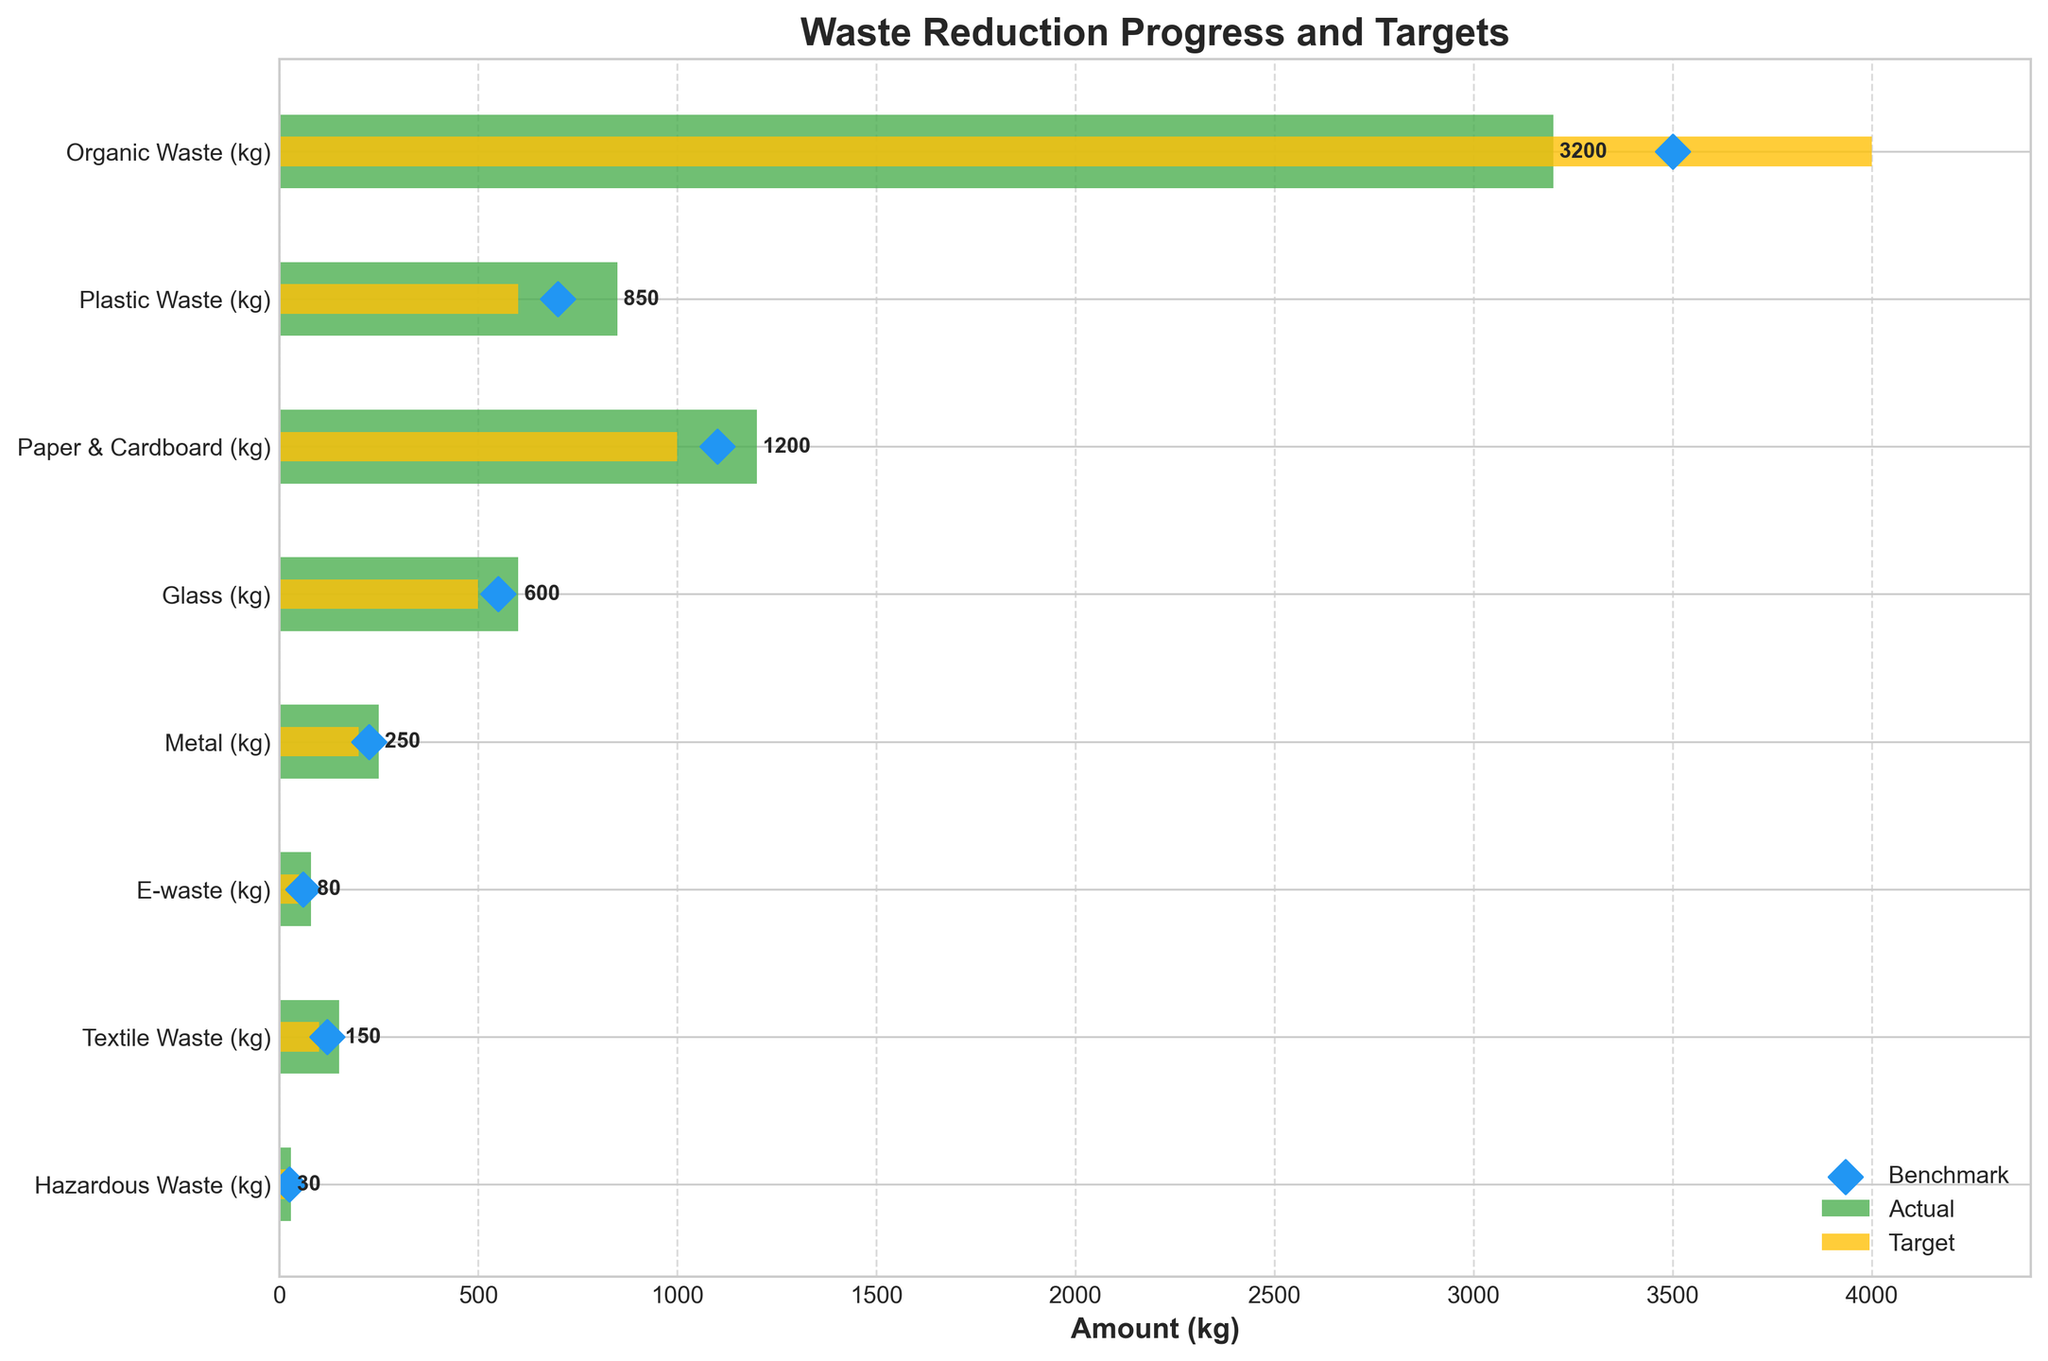Which category has the highest actual waste? By observing the actual values represented by the green bars, the Organic Waste category has the longest bar, indicating the highest actual waste.
Answer: Organic Waste Which category exceeded its target the most in terms of actual waste? To determine this, we compare the difference between the actual waste (green bars) and the target waste (yellow bars). Plastic Waste exceeds its target by the largest amount. The difference is 850 - 600 = 250 kg.
Answer: Plastic Waste What is the total actual waste from all categories? To find the total actual waste, sum all the actual values: 3200 (Organic) + 850 (Plastic) + 1200 (Paper & Cardboard) + 600 (Glass) + 250 (Metal) + 80 (E-waste) + 150 (Textile) + 30 (Hazardous). The sum is 6360 kg.
Answer: 6360 kg Which categories have actual waste values below their benchmarks? We compare the positions of the green bars (actuals) with blue diamonds (benchmarks). Plastic Waste, Paper & Cardboard, Glass, Metal, and Textile Waste have actual values above their benchmarks.
Answer: E-waste and Hazardous Waste What is the average target waste across all categories? To find the average target waste, sum all target values and divide by the number of categories: (4000 + 600 + 1000 + 500 + 200 + 50 + 100 + 20) / 8 = 6470 / 8 = 808.75 kg.
Answer: 808.75 kg Which category has the least variance between actual and benchmark values? To find this, calculate the absolute differences between actual values (green bars) and benchmark values (blue diamonds). The Metal category has an actual of 250 kg and a benchmark of 225 kg, resulting in the smallest difference of 250 - 225 = 25 kg.
Answer: Metal Are there any categories where the actual waste is less than the target but more than the benchmark? We look for categories where the green bar (actual) is between the yellow bar (target) and the blue diamond (benchmark). Paper & Cardboard fits this criterion because its actual waste (1200 kg) is less than the target (1000 kg) but more than the benchmark (1100 kg).
Answer: Paper & Cardboard Which category shows the best performance in terms of actual waste reduction compared to the target? The category where the actual waste is farthest below the target indicates better performance. E-waste shows the best performance in terms of waste reduction, with an actual waste of 80 kg compared to a target of 50 kg. The difference is -30 kg.
Answer: E-waste What percentage of the target is achieved for Textile Waste? To find this, divide the actual value by the target value and multiply by 100. For Textile Waste, (150 / 100) * 100 = 150%.
Answer: 150% 